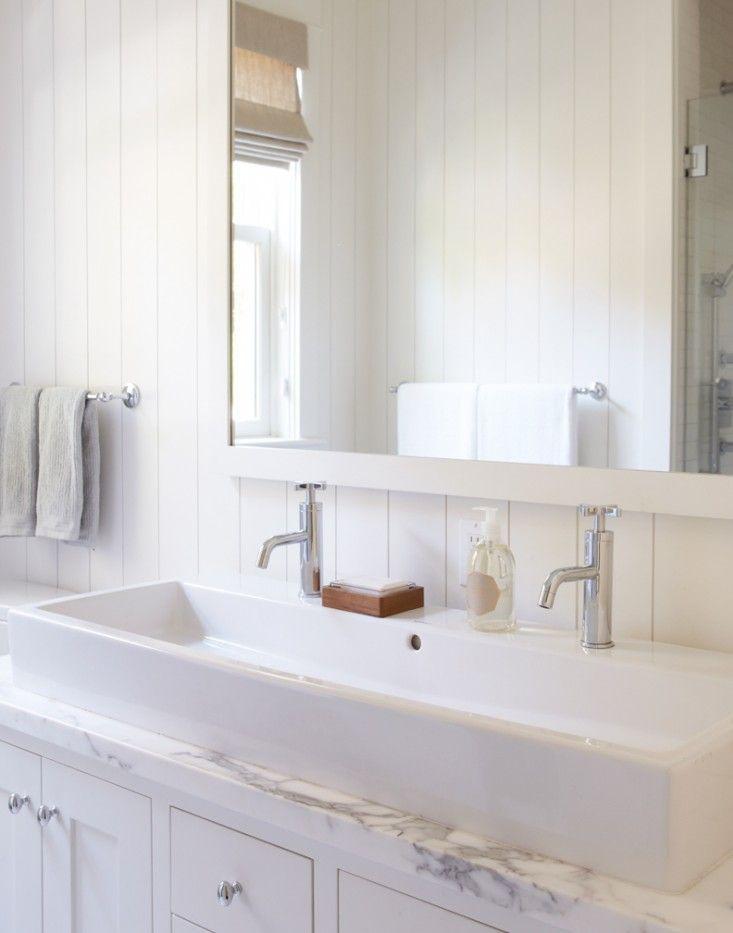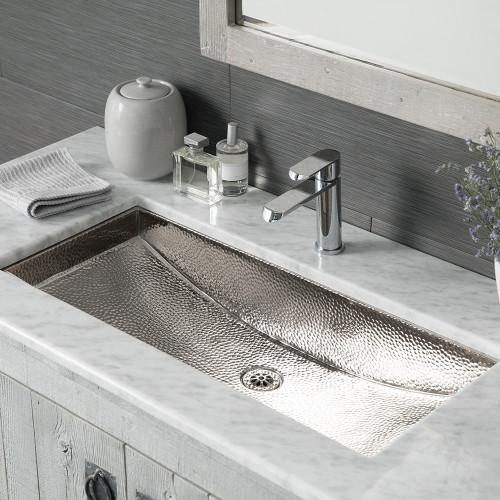The first image is the image on the left, the second image is the image on the right. Evaluate the accuracy of this statement regarding the images: "Each of the vanity sinks pictured has two faucets.". Is it true? Answer yes or no. No. 